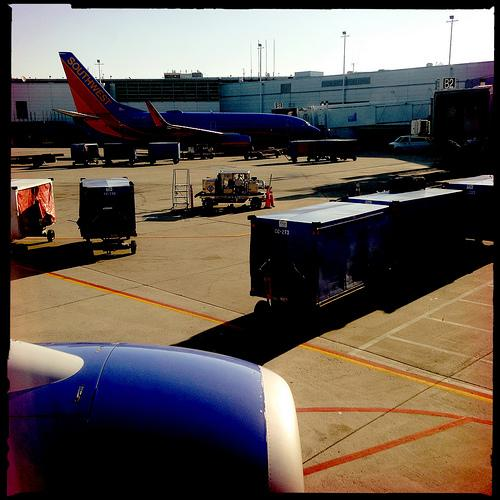Describe the most significant outdoor object in the image along with its position and color. A red and blue airplane, positioned near the airport, is the most prominent outdoor object in the image. Talk about a person or people in the image, and what they are doing or wearing. A person working in the image is seen wearing orange and standing. Mention any type of ground marking in the image and what color they are. There are orange and yellow markings on the tarmac in the image. Point out the smallest object in the image and describe its color. The smallest object in the image is an orange cone. Identify the primary vehicle in the picture and describe its color and location. The main vehicle in the image is a blue and red airplane, which is located by the airport. List two types of vehicles that are present in the image other than the main subject. In the image, there is a white cargo van and a baggage car. Depict an object located near the main object, and detail its position, color, and size. A blue and white engine is located close to the airplane and is quite large. Provide a brief description of the scene depicted in the image, focusing on vehicles, location, and people. The scene shows a blue and red airplane at the airport, surrounded by various vehicles, including baggage carriers and vans, while a person wearing orange is at work. Mention any presence of stairs or ladders in the image and describe them. There is a short ladder on the tarmac and silver ladder in the image. Describe any colors or patterns you can see in the sky and the ground in the image. The sky is a clear light blue, and the ground has grey concrete and several colored lines. 